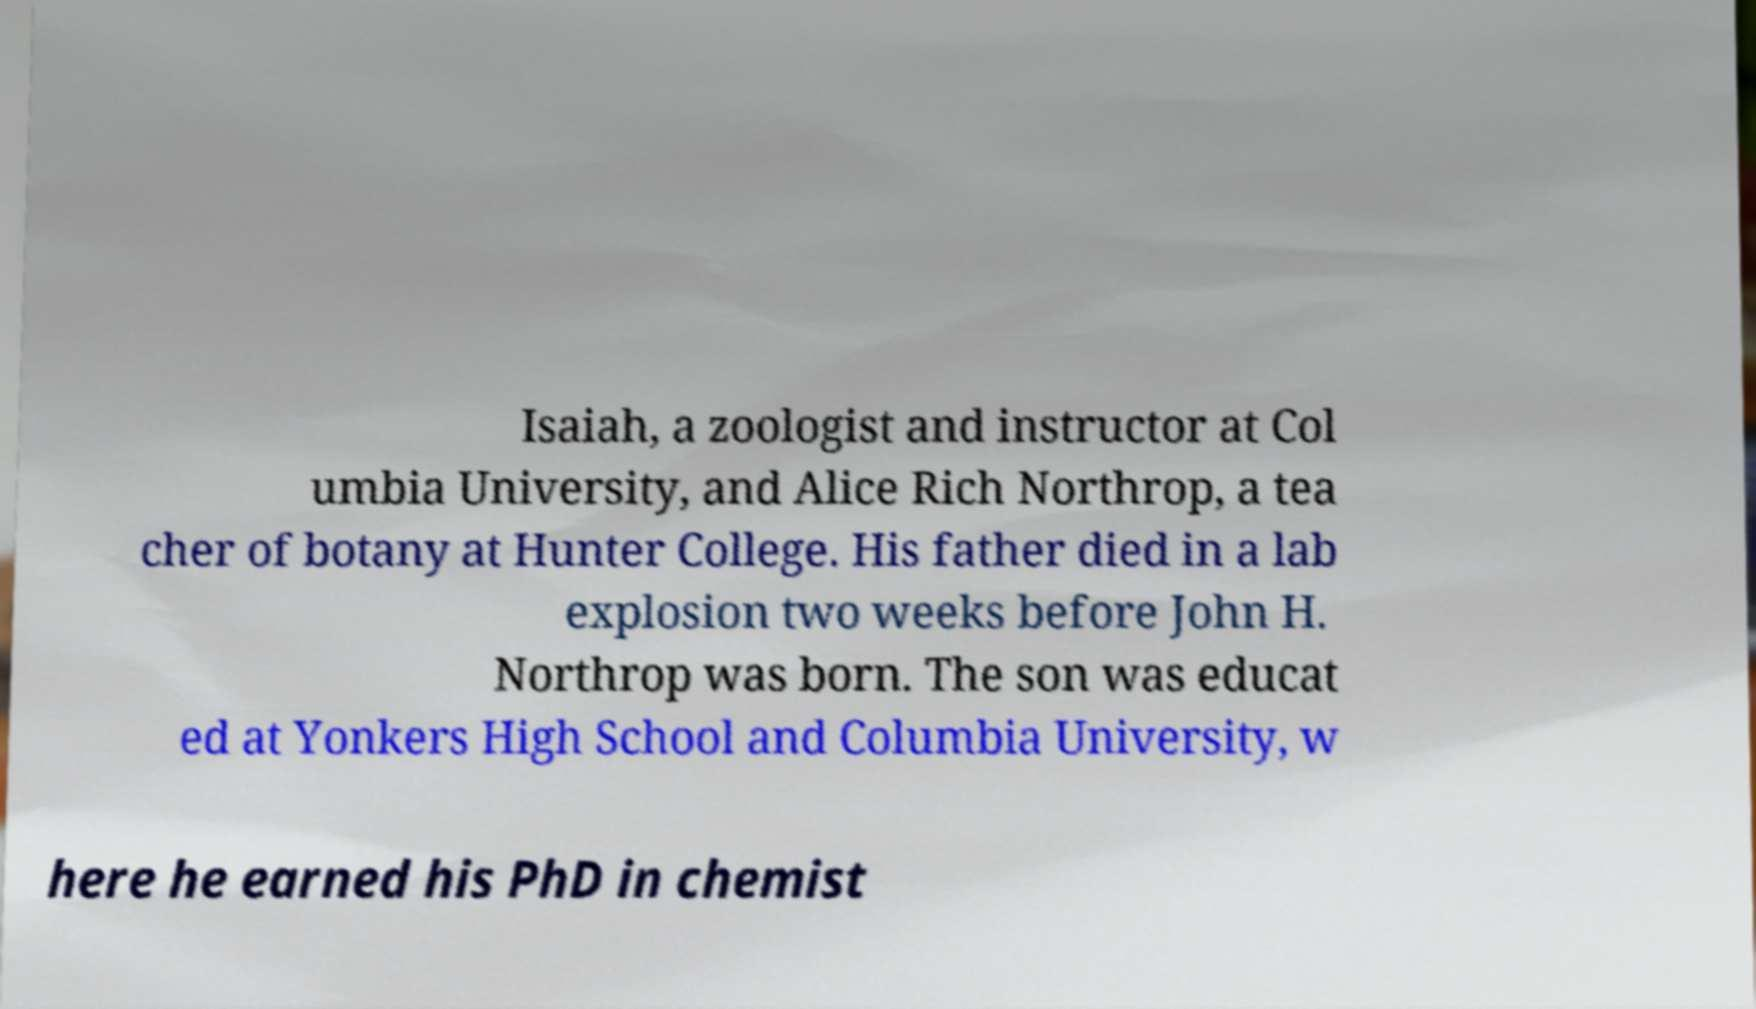Can you accurately transcribe the text from the provided image for me? Isaiah, a zoologist and instructor at Col umbia University, and Alice Rich Northrop, a tea cher of botany at Hunter College. His father died in a lab explosion two weeks before John H. Northrop was born. The son was educat ed at Yonkers High School and Columbia University, w here he earned his PhD in chemist 